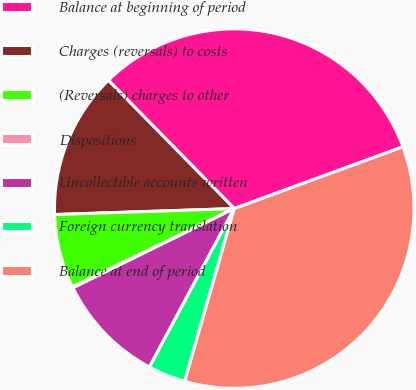Convert chart to OTSL. <chart><loc_0><loc_0><loc_500><loc_500><pie_chart><fcel>Balance at beginning of period<fcel>Charges (reversals) to costs<fcel>(Reversals) charges to other<fcel>Dispositions<fcel>Uncollectible accounts written<fcel>Foreign currency translation<fcel>Balance at end of period<nl><fcel>31.76%<fcel>13.18%<fcel>6.64%<fcel>0.1%<fcel>9.91%<fcel>3.37%<fcel>35.03%<nl></chart> 